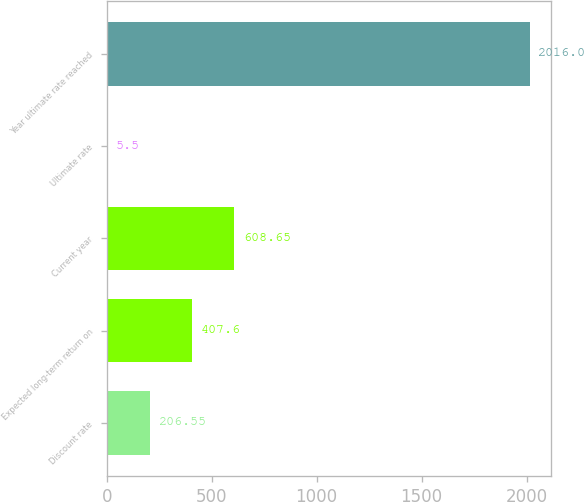Convert chart to OTSL. <chart><loc_0><loc_0><loc_500><loc_500><bar_chart><fcel>Discount rate<fcel>Expected long-term return on<fcel>Current year<fcel>Ultimate rate<fcel>Year ultimate rate reached<nl><fcel>206.55<fcel>407.6<fcel>608.65<fcel>5.5<fcel>2016<nl></chart> 